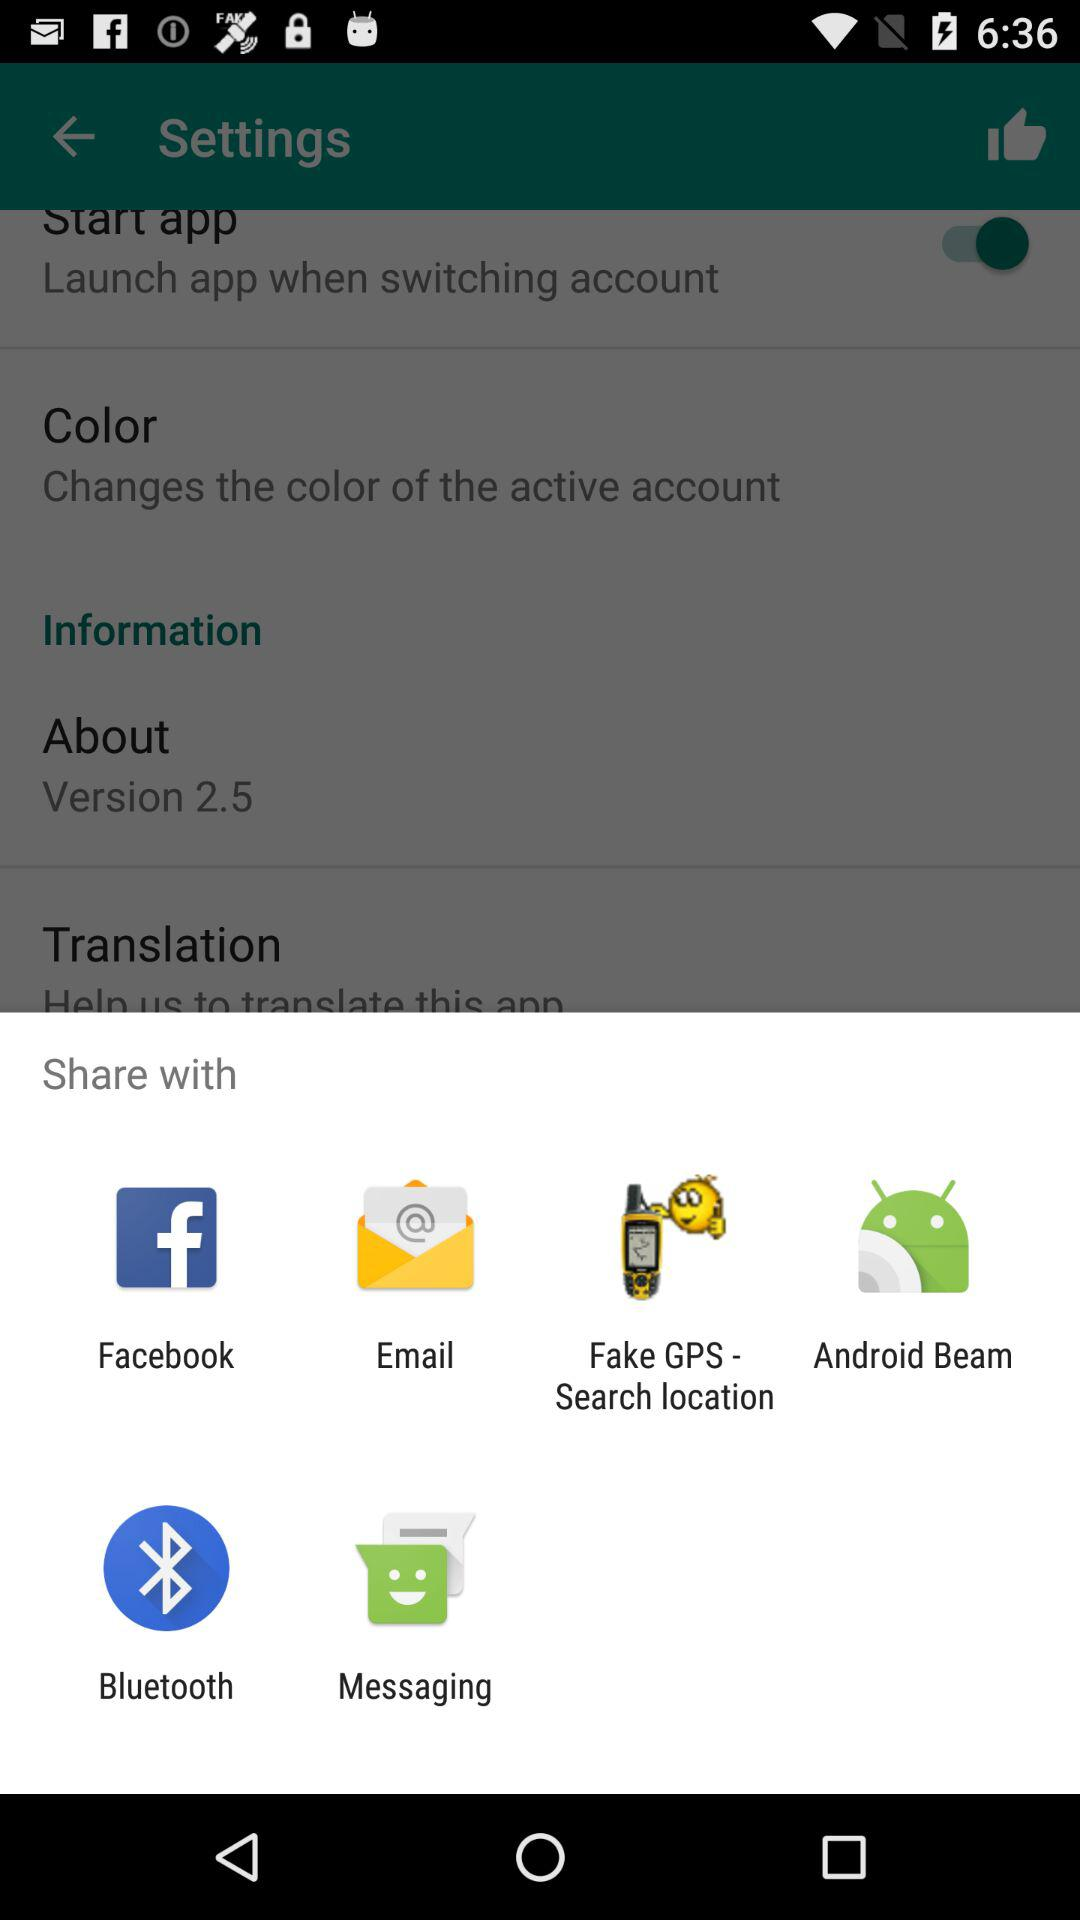Through which applications can the content be shared? The content can be shared through "Facebook", "Email", "Fake GPS - Search location", "Android Beam", "Bluetooth" and "Messaging". 